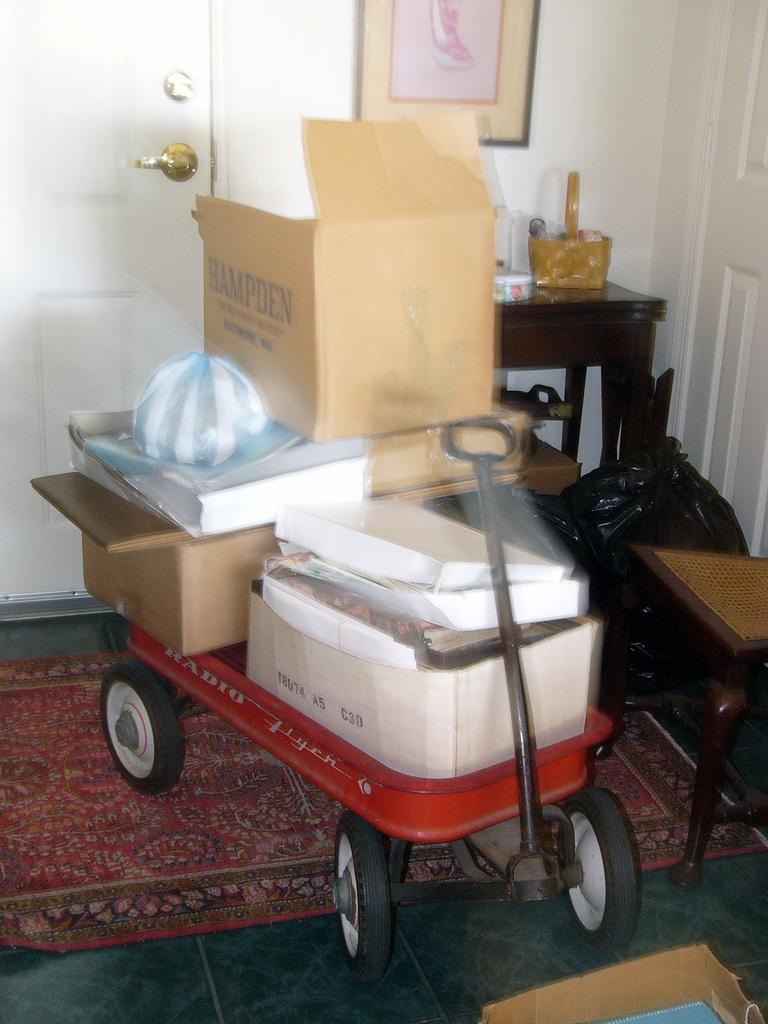How would you summarize this image in a sentence or two? In this image I can see a red color trolley and on it I can see few boxes. On these boxes I can see something is written. I can also see a red floor carpet, a chair, a black color bag, a table and on this table I can see few stuffs. In the background I can see a white door and a frame on wall. 